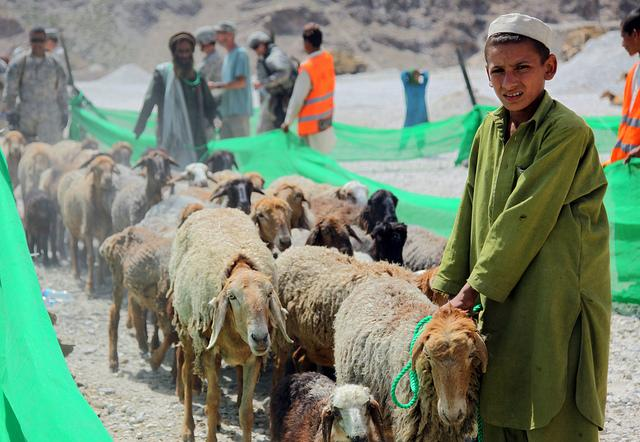Why are the men's vests orange in color?

Choices:
A) camouflage
B) dress code
C) fashion
D) visibility visibility 